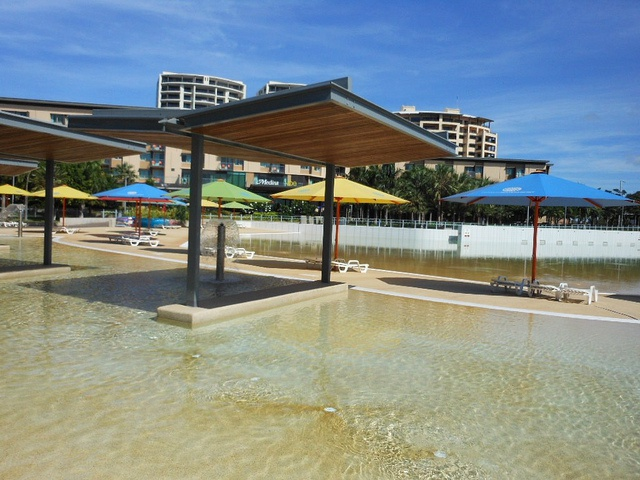Describe the objects in this image and their specific colors. I can see umbrella in darkgray, lightblue, blue, and gray tones, umbrella in darkgray, khaki, orange, and olive tones, umbrella in darkgray, lightgreen, and olive tones, umbrella in darkgray, lightblue, gray, and purple tones, and umbrella in darkgray, khaki, tan, and olive tones in this image. 